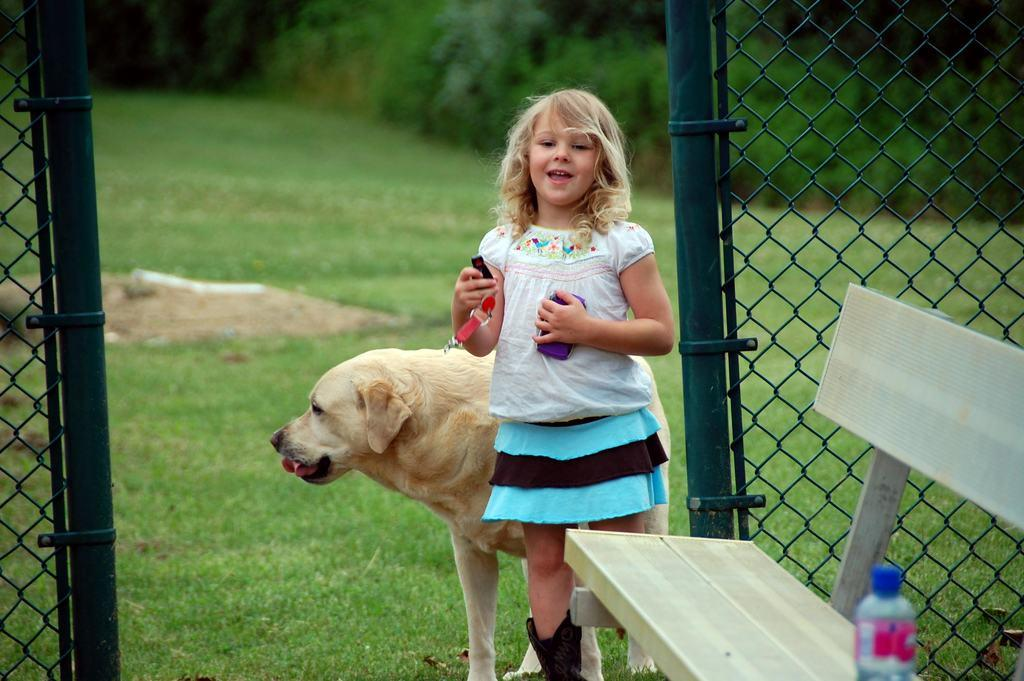Who is the main subject in the image? There is a girl in the image. What is beside the girl? There is a dog beside the girl. What is in front of the girl? There is a bench in front of the girl. What is placed on the bench? A bottle is placed on the bench. What can be seen in the background of the image? Trees are present behind the girl. What type of brush is the girl using to eat her breakfast in the image? There is no brush or breakfast present in the image. What type of gate can be seen in the image? There is no gate present in the image. 